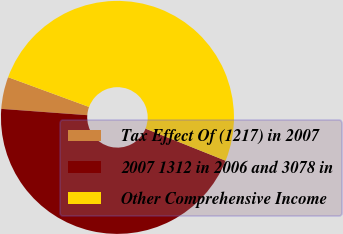Convert chart to OTSL. <chart><loc_0><loc_0><loc_500><loc_500><pie_chart><fcel>Tax Effect Of (1217) in 2007<fcel>2007 1312 in 2006 and 3078 in<fcel>Other Comprehensive Income<nl><fcel>4.44%<fcel>45.1%<fcel>50.45%<nl></chart> 